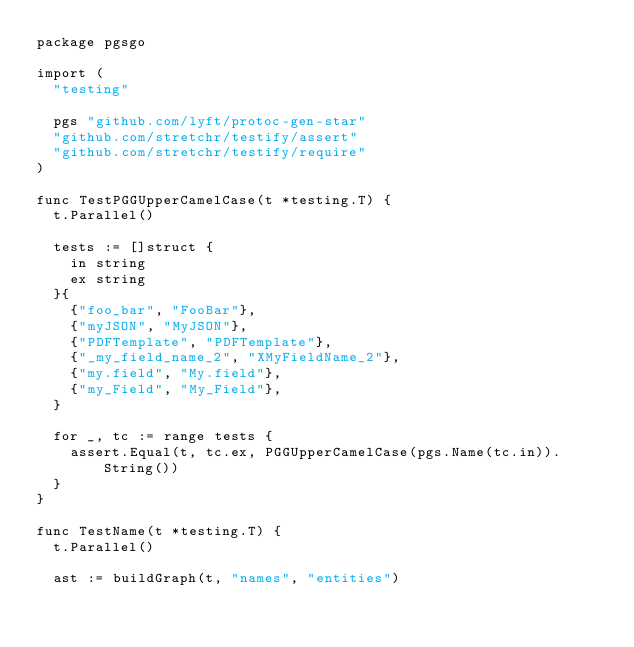Convert code to text. <code><loc_0><loc_0><loc_500><loc_500><_Go_>package pgsgo

import (
	"testing"

	pgs "github.com/lyft/protoc-gen-star"
	"github.com/stretchr/testify/assert"
	"github.com/stretchr/testify/require"
)

func TestPGGUpperCamelCase(t *testing.T) {
	t.Parallel()

	tests := []struct {
		in string
		ex string
	}{
		{"foo_bar", "FooBar"},
		{"myJSON", "MyJSON"},
		{"PDFTemplate", "PDFTemplate"},
		{"_my_field_name_2", "XMyFieldName_2"},
		{"my.field", "My.field"},
		{"my_Field", "My_Field"},
	}

	for _, tc := range tests {
		assert.Equal(t, tc.ex, PGGUpperCamelCase(pgs.Name(tc.in)).String())
	}
}

func TestName(t *testing.T) {
	t.Parallel()

	ast := buildGraph(t, "names", "entities")</code> 